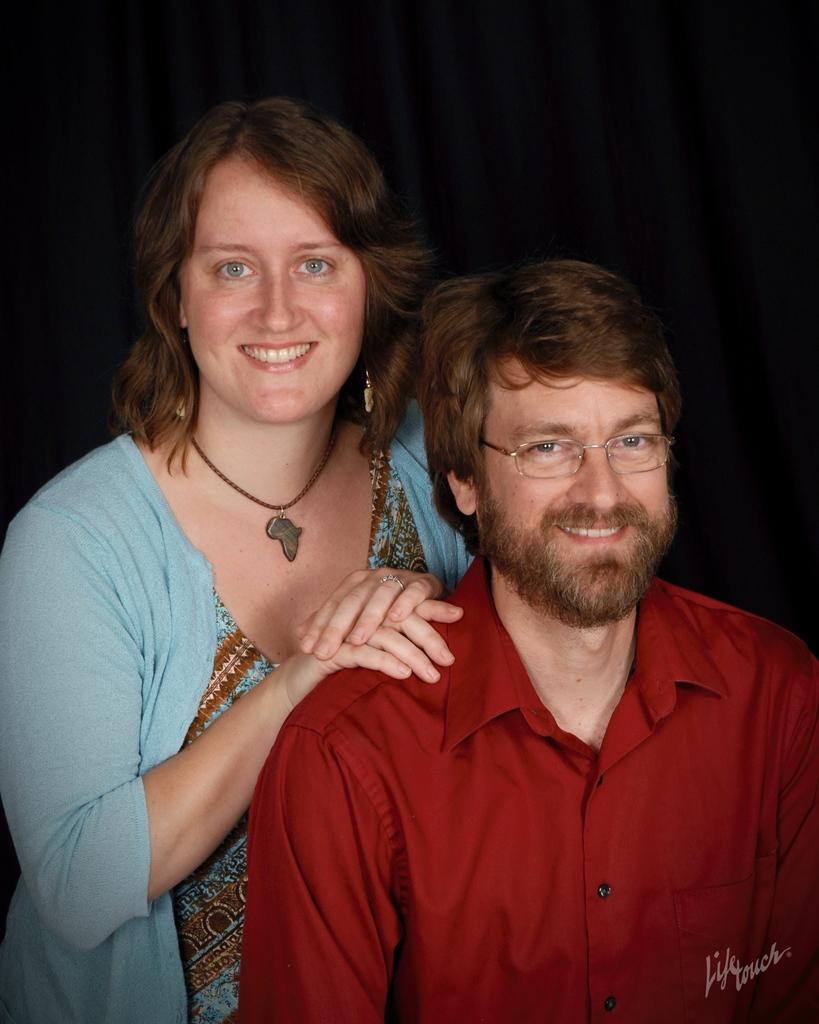Who is present in the image? There is a man and a woman in the image. What are the facial expressions of the people in the image? Both the man and woman are smiling in the image. What can be seen in the background of the image? There is a black curtain in the background of the image. What accessory is the woman wearing? The woman is wearing a necklace around her neck. What type of home can be seen in the background of the image? There is no home visible in the background of the image; only a black curtain is present. What form of scissors is being used by the man in the image? There are no scissors present in the image. 